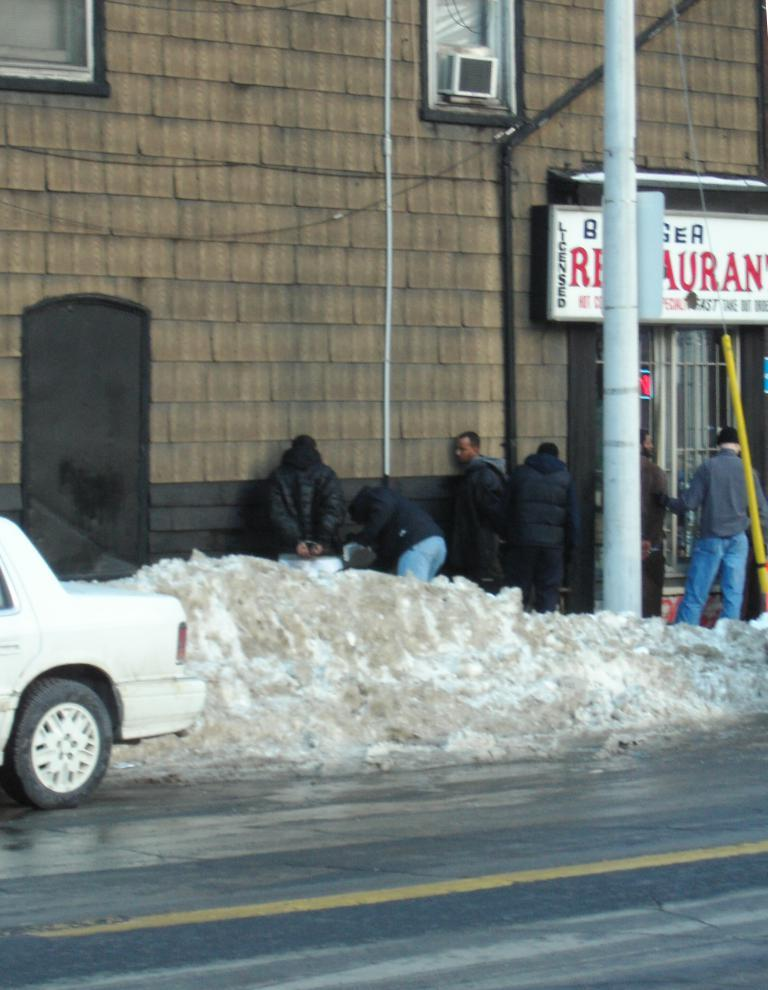What is located at the bottom of the image? There is a road at the bottom of the image. What can be seen on the right side of the image? There are men standing on the right side of the image. What are the men wearing? The men are wearing black coats. What is on the left side of the image? There is a building on the left side of the image. What is present on the road? There is a vehicle on the road. Where is the rabbit in the image? There is no rabbit present in the image. What decision are the men making in the image? The image does not provide information about any decisions being made by the men. 